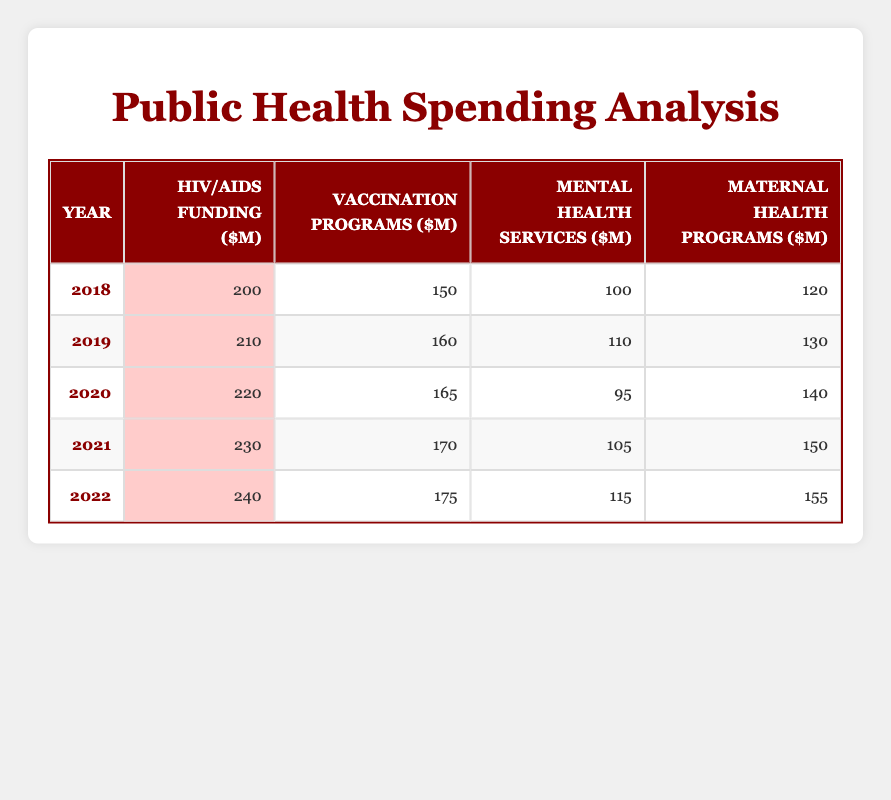What was the HIV/AIDS funding in 2021? The table shows the data for 2021 where the column for HIV/AIDS funding clearly states the amount as 230 million.
Answer: 230 million Which year had the highest Vaccination Programs funding? Looking through the Vaccination Programs column, the highest value is 175 million, which corresponds to the year 2022.
Answer: 2022 What is the total funding for Mental Health Services from 2018 to 2022? To find the total, add the values: 100 + 110 + 95 + 105 + 115 = 525 million.
Answer: 525 million Was there an increase in Maternal Health Programs funding from 2019 to 2020? The value for Maternal Health Programs in 2019 is 130 million and in 2020 it is 140 million; since 140 is greater than 130, it indicates an increase.
Answer: Yes What is the average funding for HIV/AIDS over the five years? To find the average, sum the amounts: 200 + 210 + 220 + 230 + 240 = 1100 million, then divide by the number of years, which is 5. Thus, 1100/5 = 220 million.
Answer: 220 million In which year did Mental Health Services funding drop compared to the previous year? Comparing the years, the funding dropped from 110 million in 2019 to 95 million in 2020, indicating the only decrease from one year to the next.
Answer: 2020 What was the funding for Vaccination Programs in 2019 compared to 2021? The funding in 2019 is 160 million, while in 2021 it is 170 million; therefore, the funding increased from 2019 to 2021.
Answer: An increase How much more was spent on HIV/AIDS in 2022 compared to 2018? The funding for HIV/AIDS in 2022 is 240 million, and in 2018 it was 200 million. The difference is 240 - 200 = 40 million.
Answer: 40 million Was the total funding for HIV/AIDS higher than the total for Mental Health Services across the five years? The total funding for HIV/AIDS is 1100 million, and the total for Mental Health Services is 525 million. Since 1100 million is greater than 525 million, the answer is yes.
Answer: Yes 